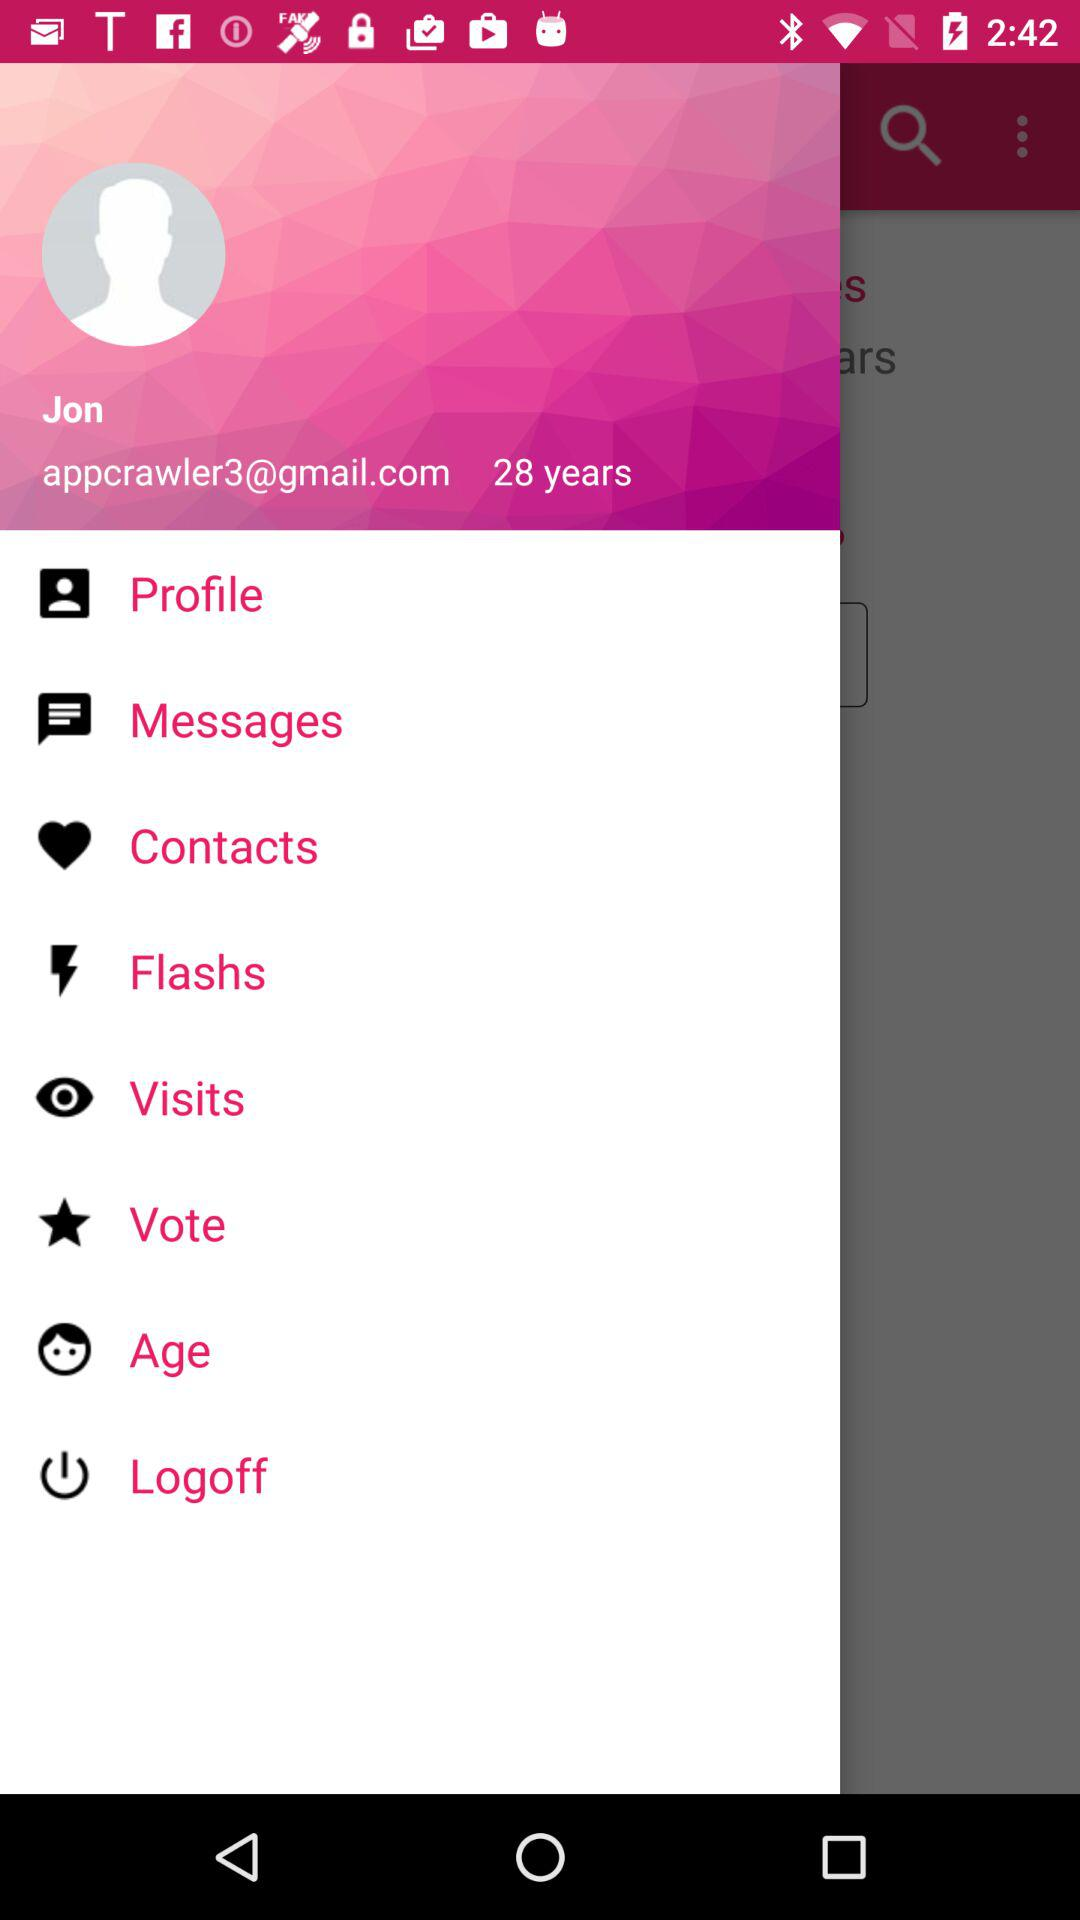What are the available options? The available options are "Profile", "Messages", "Contacts", "Flashs", "Visits", "Vote", "Age" and "Logoff". 